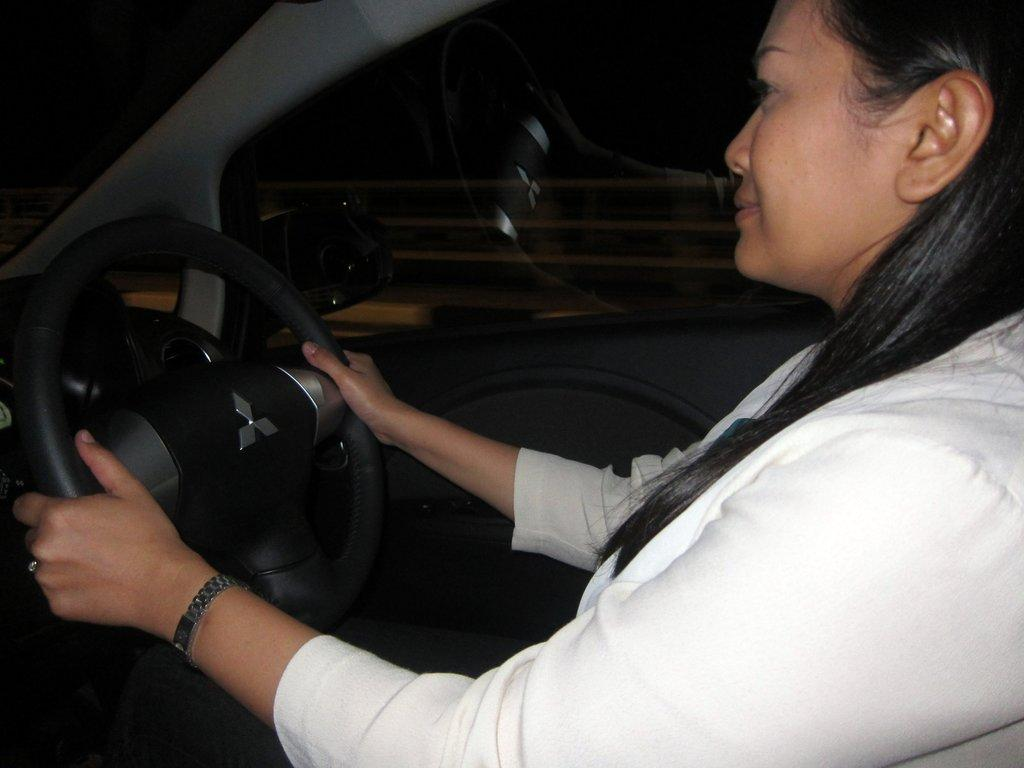Who is the main subject in the image? There is a woman in the image. What is the woman doing in the image? The woman is driving a car. What is the woman holding while driving the car? The woman is holding a black steering wheel. What is the woman wearing in the image? The woman is wearing a white dress. What type of boot can be seen in the image? There is no boot present in the image. What kind of vessel is the woman using to navigate the water in the image? The image does not depict the woman navigating water or using a vessel; she is driving a car. 